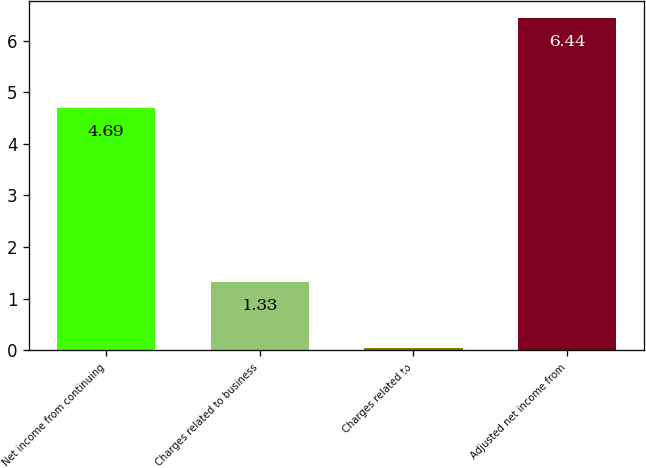<chart> <loc_0><loc_0><loc_500><loc_500><bar_chart><fcel>Net income from continuing<fcel>Charges related to business<fcel>Charges related to<fcel>Adjusted net income from<nl><fcel>4.69<fcel>1.33<fcel>0.05<fcel>6.44<nl></chart> 